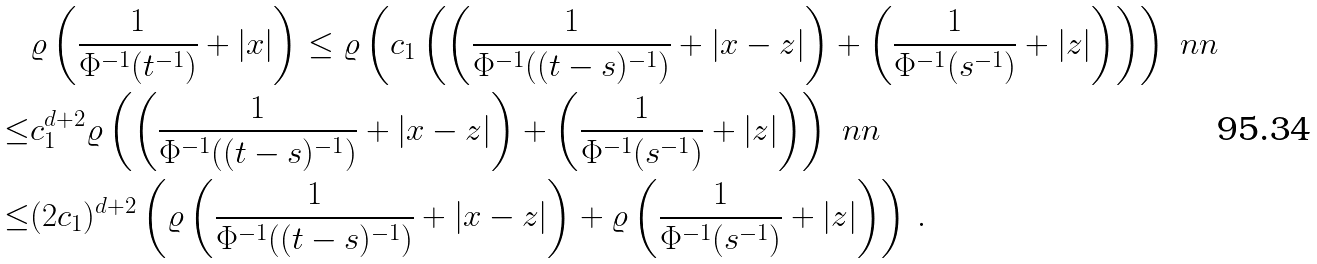<formula> <loc_0><loc_0><loc_500><loc_500>& \varrho \left ( \frac { 1 } { \Phi ^ { - 1 } ( t ^ { - 1 } ) } + | x | \right ) \leq \varrho \left ( c _ { 1 } \left ( \left ( \frac { 1 } { \Phi ^ { - 1 } ( ( t - s ) ^ { - 1 } ) } + | x - z | \right ) + \left ( \frac { 1 } { \Phi ^ { - 1 } ( s ^ { - 1 } ) } + | z | \right ) \right ) \right ) \ n n \\ \leq & c _ { 1 } ^ { d + 2 } \varrho \left ( \left ( \frac { 1 } { \Phi ^ { - 1 } ( ( t - s ) ^ { - 1 } ) } + | x - z | \right ) + \left ( \frac { 1 } { \Phi ^ { - 1 } ( s ^ { - 1 } ) } + | z | \right ) \right ) \ n n \\ \leq & ( 2 c _ { 1 } ) ^ { d + 2 } \left ( \varrho \left ( \frac { 1 } { \Phi ^ { - 1 } ( ( t - s ) ^ { - 1 } ) } + | x - z | \right ) + \varrho \left ( \frac { 1 } { \Phi ^ { - 1 } ( s ^ { - 1 } ) } + | z | \right ) \right ) \, .</formula> 